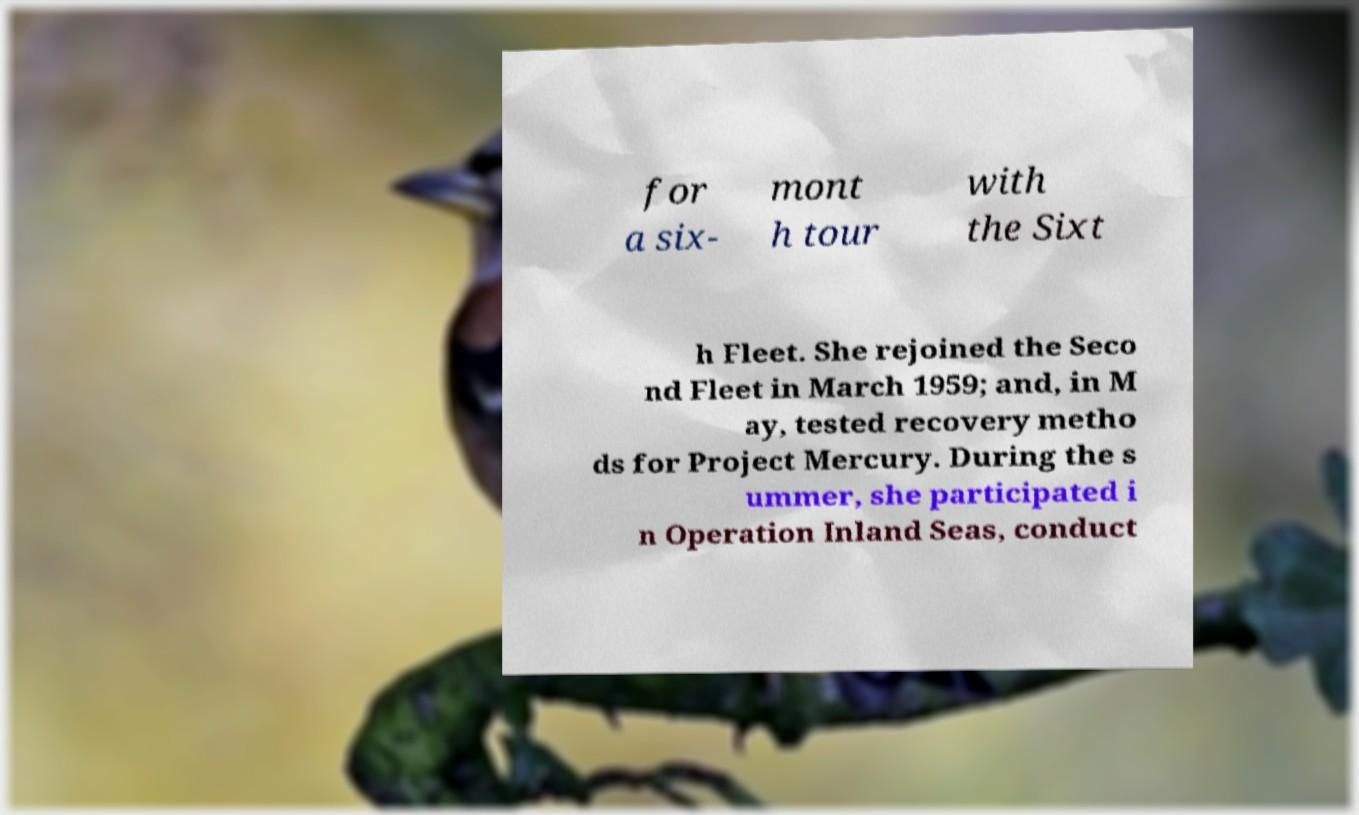Could you extract and type out the text from this image? for a six- mont h tour with the Sixt h Fleet. She rejoined the Seco nd Fleet in March 1959; and, in M ay, tested recovery metho ds for Project Mercury. During the s ummer, she participated i n Operation Inland Seas, conduct 